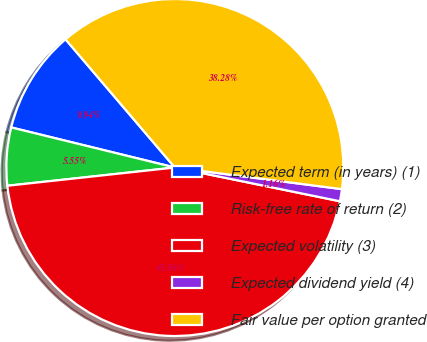<chart> <loc_0><loc_0><loc_500><loc_500><pie_chart><fcel>Expected term (in years) (1)<fcel>Risk-free rate of return (2)<fcel>Expected volatility (3)<fcel>Expected dividend yield (4)<fcel>Fair value per option granted<nl><fcel>9.94%<fcel>5.55%<fcel>45.06%<fcel>1.16%<fcel>38.28%<nl></chart> 